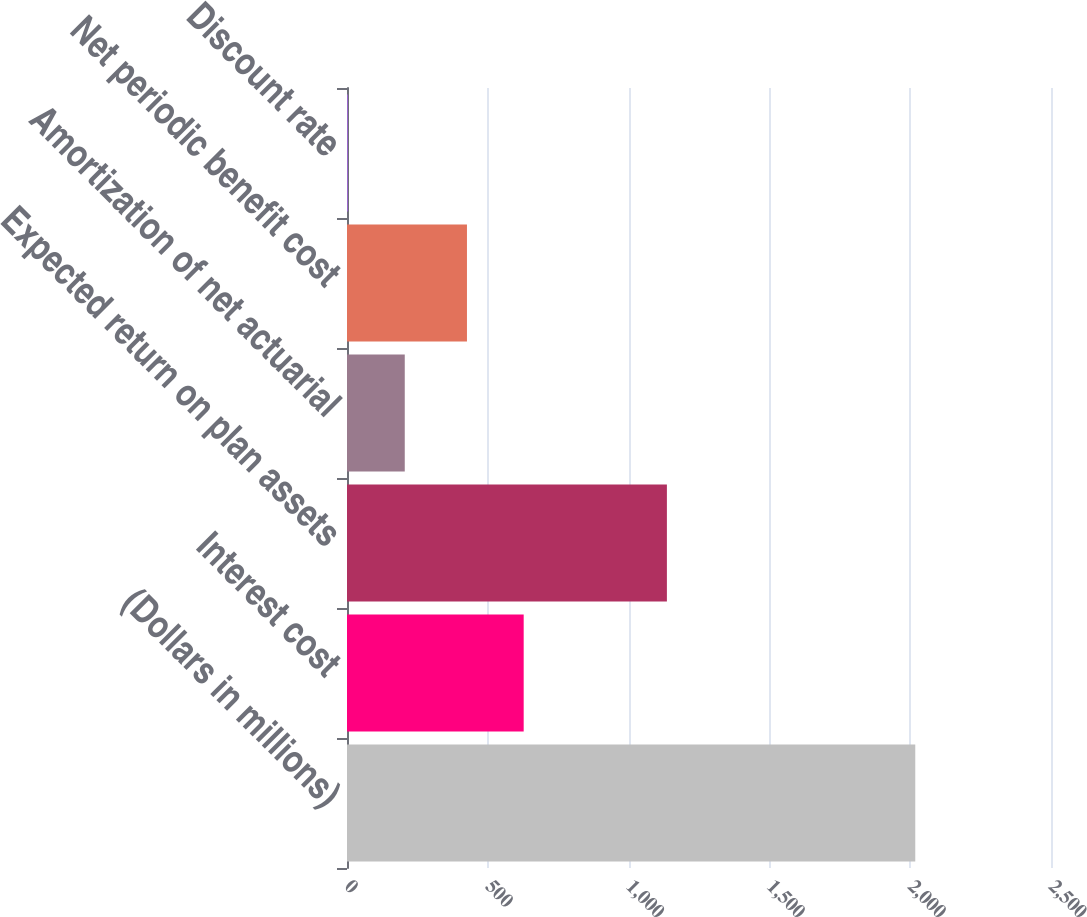Convert chart to OTSL. <chart><loc_0><loc_0><loc_500><loc_500><bar_chart><fcel>(Dollars in millions)<fcel>Interest cost<fcel>Expected return on plan assets<fcel>Amortization of net actuarial<fcel>Net periodic benefit cost<fcel>Discount rate<nl><fcel>2018<fcel>627.43<fcel>1136<fcel>205.11<fcel>426<fcel>3.68<nl></chart> 